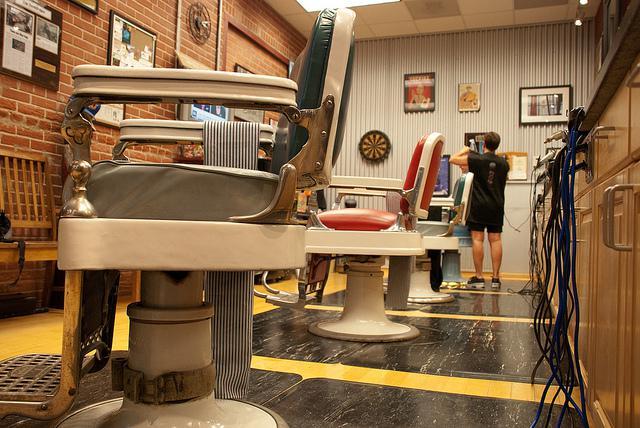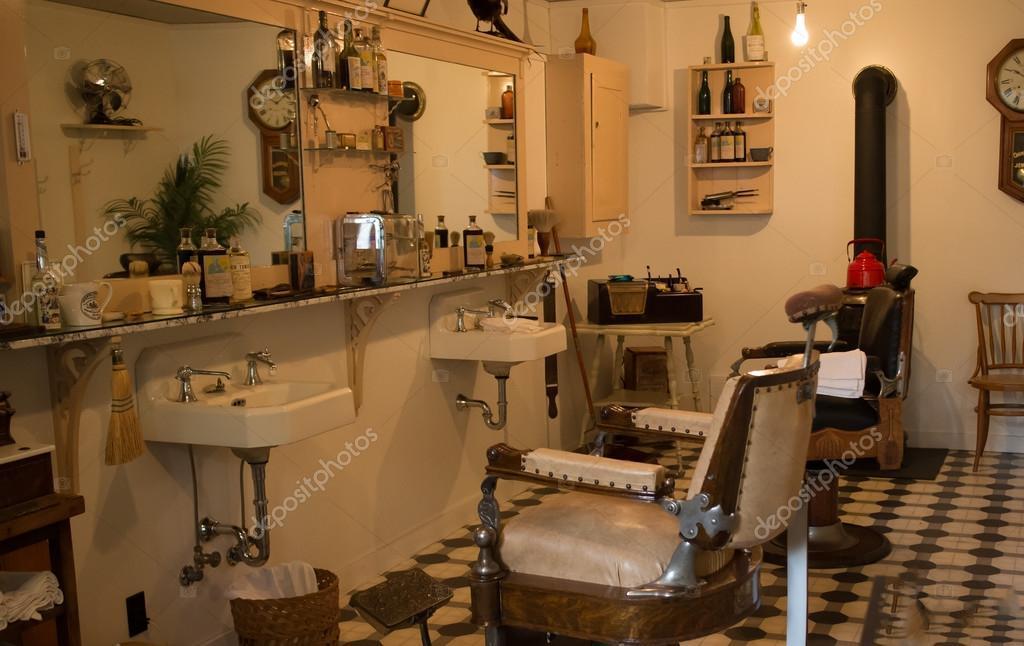The first image is the image on the left, the second image is the image on the right. Analyze the images presented: Is the assertion "The right image shows an empty barber chair turned leftward and facing a horizontal surface piled with items." valid? Answer yes or no. Yes. The first image is the image on the left, the second image is the image on the right. Assess this claim about the two images: "In at least one image there are three barber chairs". Correct or not? Answer yes or no. Yes. 